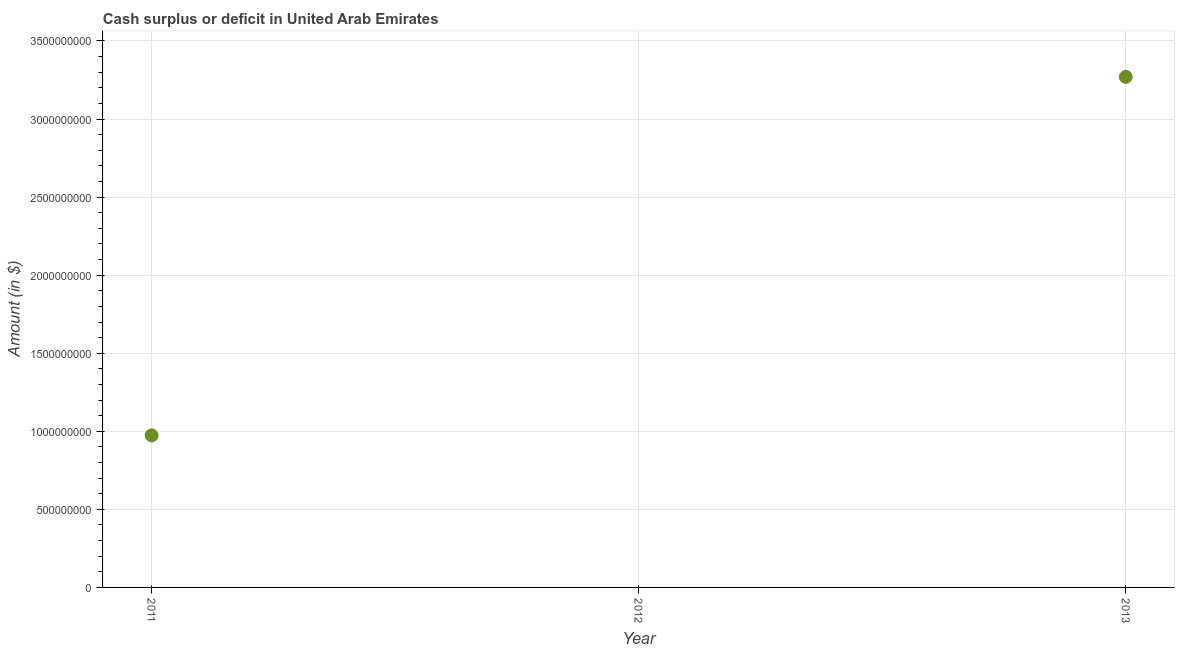What is the cash surplus or deficit in 2011?
Make the answer very short. 9.74e+08. Across all years, what is the maximum cash surplus or deficit?
Provide a short and direct response. 3.27e+09. What is the sum of the cash surplus or deficit?
Offer a terse response. 4.24e+09. What is the difference between the cash surplus or deficit in 2011 and 2013?
Your answer should be very brief. -2.30e+09. What is the average cash surplus or deficit per year?
Make the answer very short. 1.41e+09. What is the median cash surplus or deficit?
Keep it short and to the point. 9.74e+08. In how many years, is the cash surplus or deficit greater than 900000000 $?
Make the answer very short. 2. What is the ratio of the cash surplus or deficit in 2011 to that in 2013?
Ensure brevity in your answer.  0.3. Is the cash surplus or deficit in 2011 less than that in 2013?
Give a very brief answer. Yes. Is the sum of the cash surplus or deficit in 2011 and 2013 greater than the maximum cash surplus or deficit across all years?
Your response must be concise. Yes. What is the difference between the highest and the lowest cash surplus or deficit?
Make the answer very short. 3.27e+09. In how many years, is the cash surplus or deficit greater than the average cash surplus or deficit taken over all years?
Offer a very short reply. 1. How many years are there in the graph?
Your answer should be very brief. 3. Does the graph contain any zero values?
Your answer should be compact. Yes. Does the graph contain grids?
Your answer should be compact. Yes. What is the title of the graph?
Your response must be concise. Cash surplus or deficit in United Arab Emirates. What is the label or title of the Y-axis?
Your response must be concise. Amount (in $). What is the Amount (in $) in 2011?
Your answer should be very brief. 9.74e+08. What is the Amount (in $) in 2013?
Make the answer very short. 3.27e+09. What is the difference between the Amount (in $) in 2011 and 2013?
Offer a terse response. -2.30e+09. What is the ratio of the Amount (in $) in 2011 to that in 2013?
Keep it short and to the point. 0.3. 